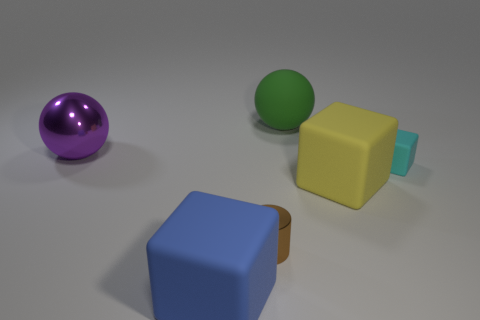Add 3 purple shiny balls. How many objects exist? 9 Subtract all cylinders. How many objects are left? 5 Add 4 big things. How many big things exist? 8 Subtract 0 purple cylinders. How many objects are left? 6 Subtract all small rubber objects. Subtract all blue rubber cubes. How many objects are left? 4 Add 6 large yellow objects. How many large yellow objects are left? 7 